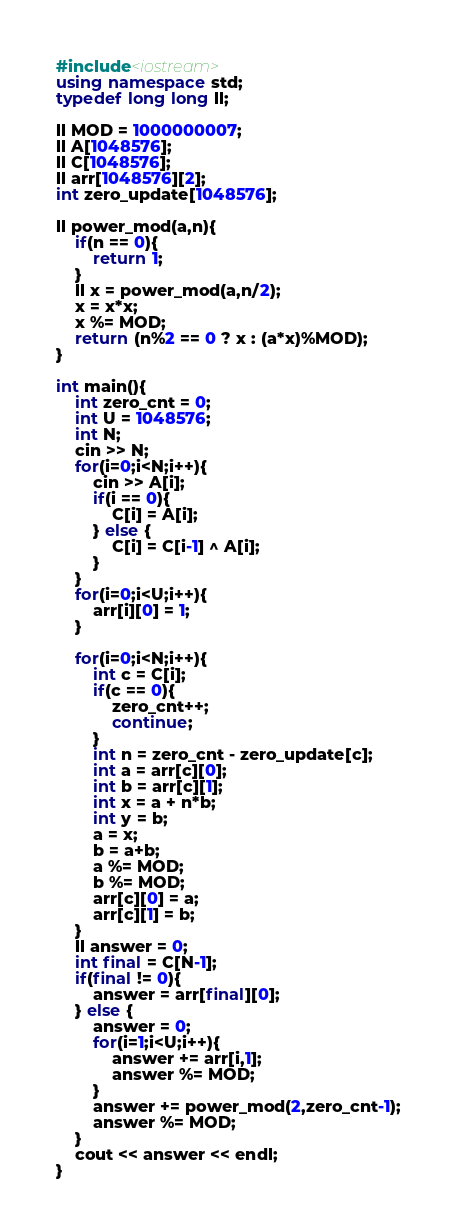Convert code to text. <code><loc_0><loc_0><loc_500><loc_500><_C++_>#include<iostream>
using namespace std;
typedef long long ll;

ll MOD = 1000000007;
ll A[1048576];
ll C[1048576];
ll arr[1048576][2];
int zero_update[1048576];

ll power_mod(a,n){
	if(n == 0){
		return 1;
	}
	ll x = power_mod(a,n/2);
	x = x*x;
	x %= MOD;
	return (n%2 == 0 ? x : (a*x)%MOD);
}

int main(){
	int zero_cnt = 0;
	int U = 1048576;
	int N;
	cin >> N;
	for(i=0;i<N;i++){
		cin >> A[i];
		if(i == 0){
			C[i] = A[i];
		} else {
			C[i] = C[i-1] ^ A[i];
		}
	}
	for(i=0;i<U;i++){
		arr[i][0] = 1;
	}
	
	for(i=0;i<N;i++){
		int c = C[i];
		if(c == 0){
			zero_cnt++;
			continue;
		}
		int n = zero_cnt - zero_update[c];
		int a = arr[c][0];
		int b = arr[c][1];
		int x = a + n*b;
		int y = b;
		a = x;
		b = a+b;
		a %= MOD;
		b %= MOD;
		arr[c][0] = a;
		arr[c][1] = b;
	}
	ll answer = 0;
	int final = C[N-1];
	if(final != 0){
		answer = arr[final][0];
	} else {
		answer = 0;
		for(i=1;i<U;i++){
			answer += arr[i,1];
			answer %= MOD;
		}
		answer += power_mod(2,zero_cnt-1);
		answer %= MOD;
	}
	cout << answer << endl;
}
</code> 